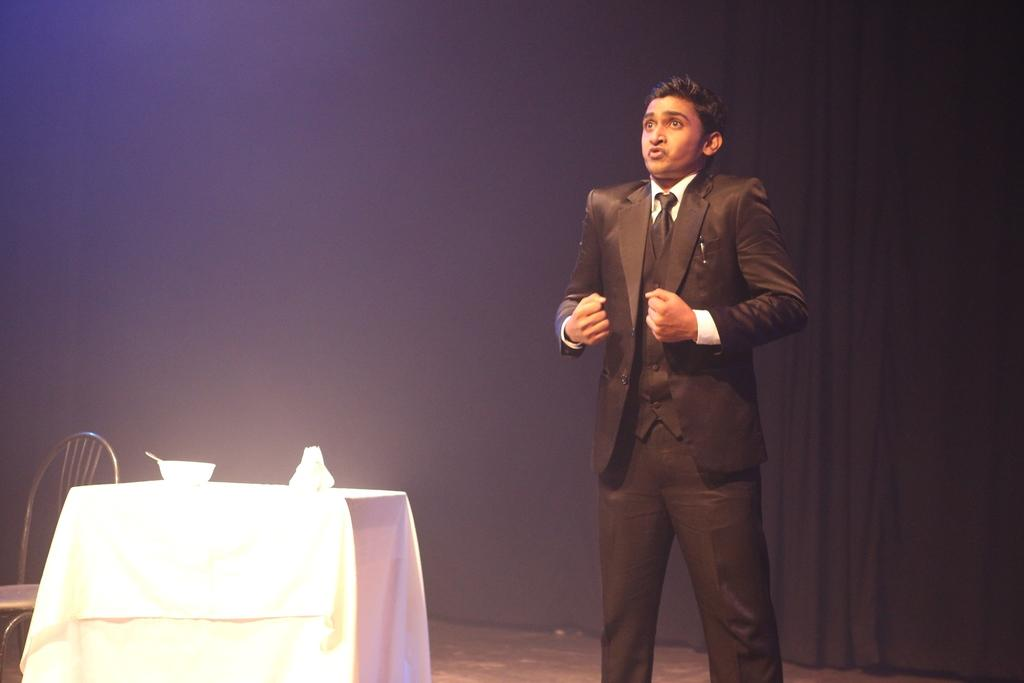What is the man doing in the image? There is a man standing in the image. What is on the table in the image? There is a cloth, a bowl, and an object on the table. What type of furniture is present in the image? There is a chair in the image. What can be seen in the background of the image? There is a curtain in the background of the image. What type of voice can be heard coming from the duck in the image? There is no duck present in the image, so it is not possible to determine what type of voice might be heard. 